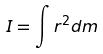<formula> <loc_0><loc_0><loc_500><loc_500>I = \int r ^ { 2 } d m</formula> 